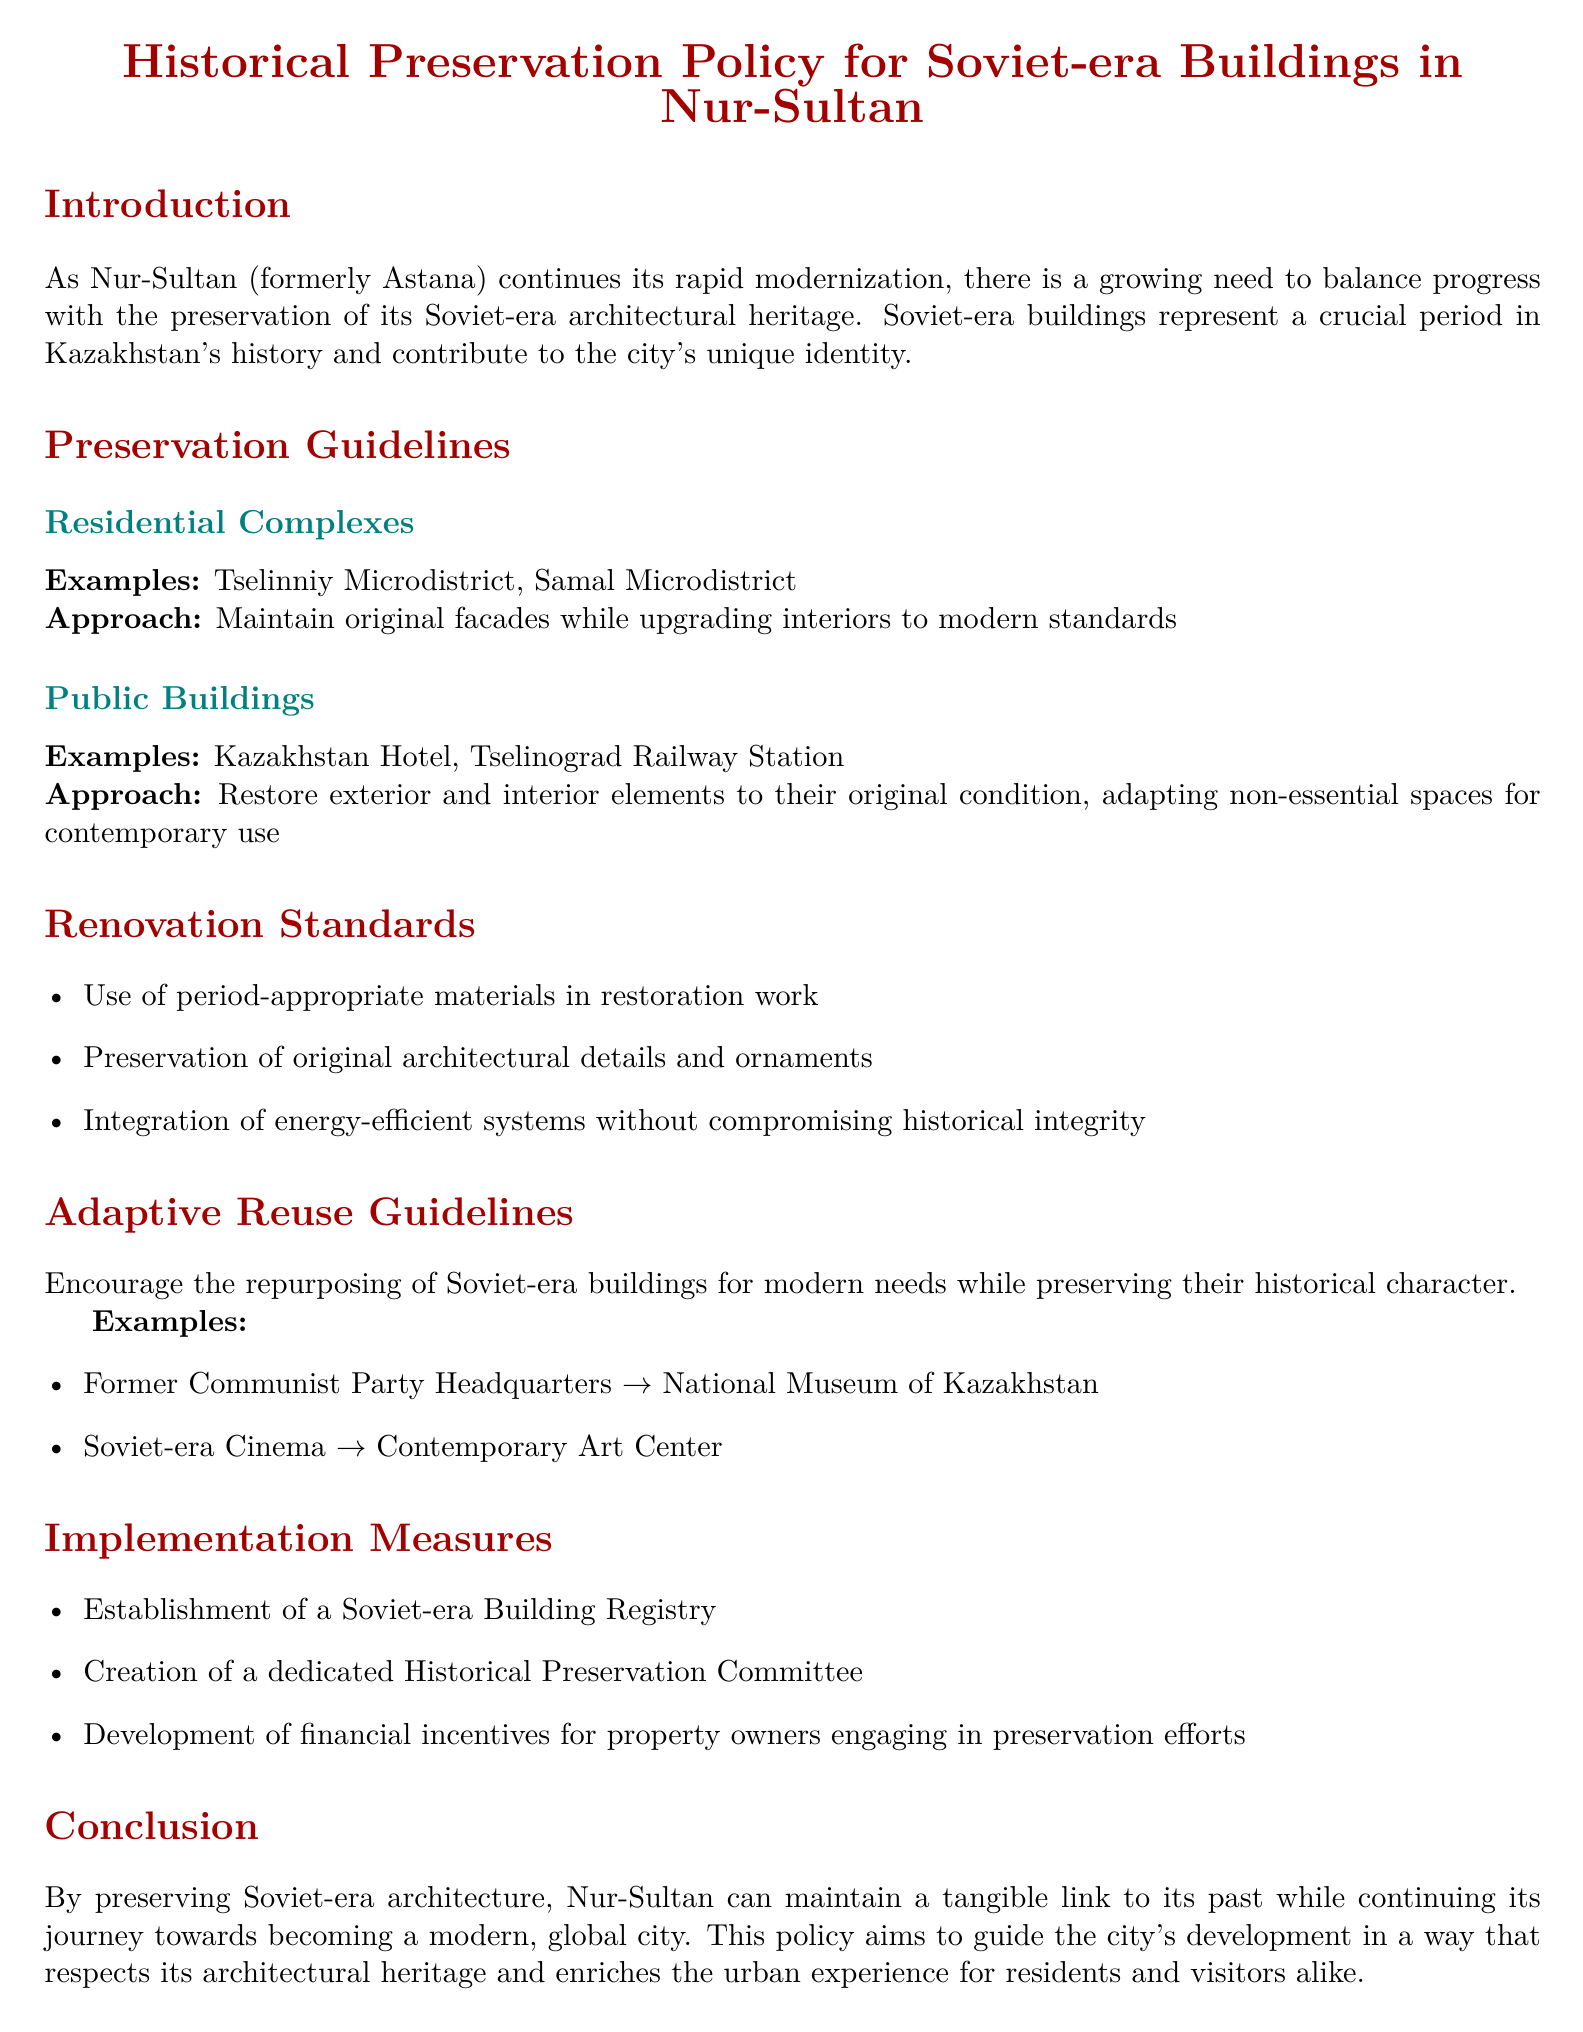What is the main focus of the policy document? The document focuses on balancing modernization with the preservation of Soviet-era architectural heritage in Nur-Sultan.
Answer: Preservation of Soviet-era architectural heritage What are the examples of residential complexes mentioned? The examples of residential complexes listed in the document are specific areas in Nur-Sultan.
Answer: Tselinniy Microdistrict, Samal Microdistrict What is the approach for public buildings? The document details specific renovation approaches for public buildings in Nur-Sultan concerning their exterior and interior.
Answer: Restore exterior and interior elements to their original condition What type of materials should be used in restoration work? The document specifies the type of materials that should be used during the renovation of Soviet-era buildings.
Answer: Period-appropriate materials What is one of the examples of adaptive reuse mentioned? The document provides an example of how a Soviet-era building can be repurposed for modern use while maintaining its historical character.
Answer: Former Communist Party Headquarters → National Museum of Kazakhstan What is the purpose of establishing a Soviet-era Building Registry? The document outlines implementation measures to facilitate the preservation efforts for Soviet-era buildings.
Answer: To preserve and manage Soviet-era buildings How many implementation measures are listed in the document? The document details the number of implementation measures designed to support the historical preservation policy.
Answer: Three What is the color used for section titles in the document? The document specifies a color theme for section titles, reflecting the historical context.
Answer: Soviet red 